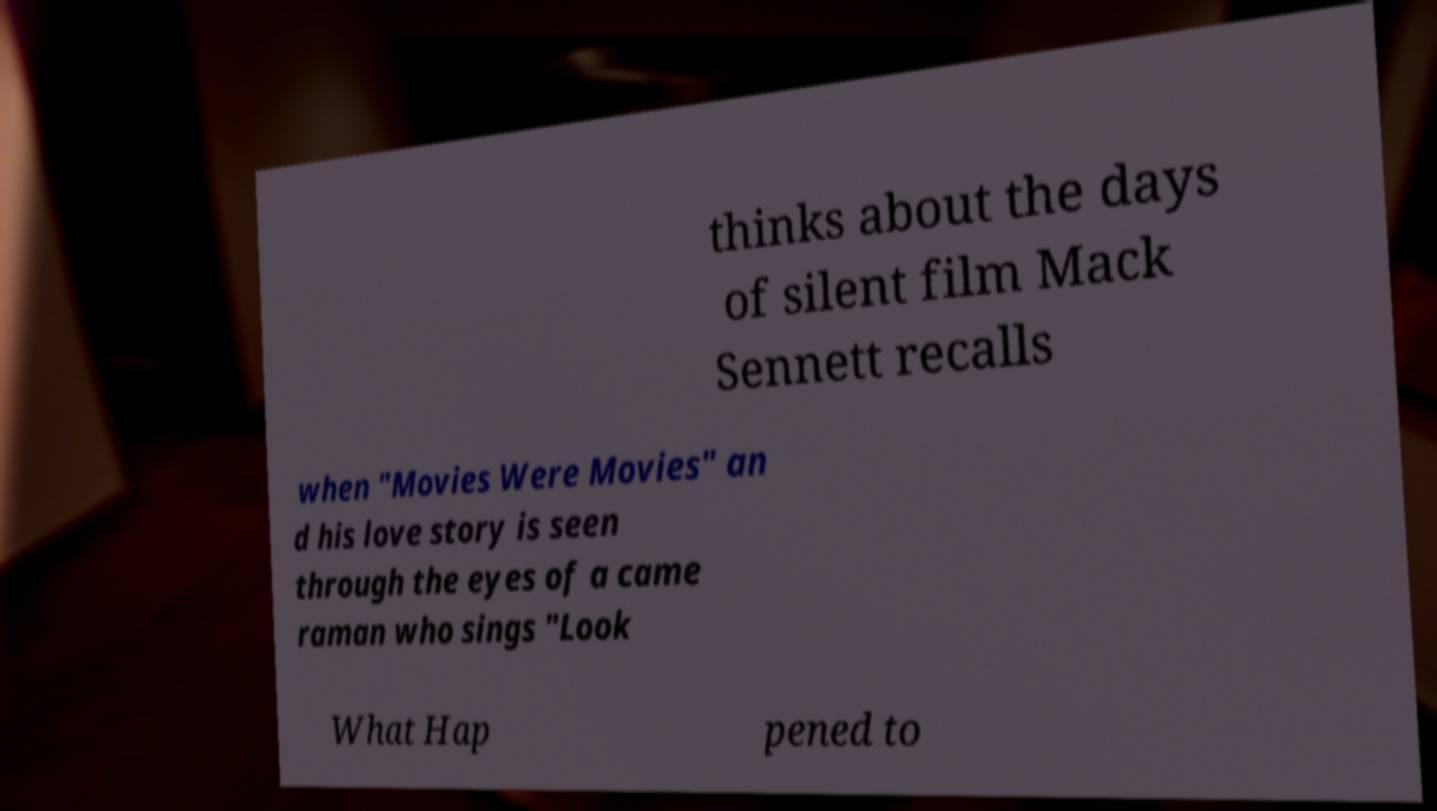For documentation purposes, I need the text within this image transcribed. Could you provide that? thinks about the days of silent film Mack Sennett recalls when "Movies Were Movies" an d his love story is seen through the eyes of a came raman who sings "Look What Hap pened to 